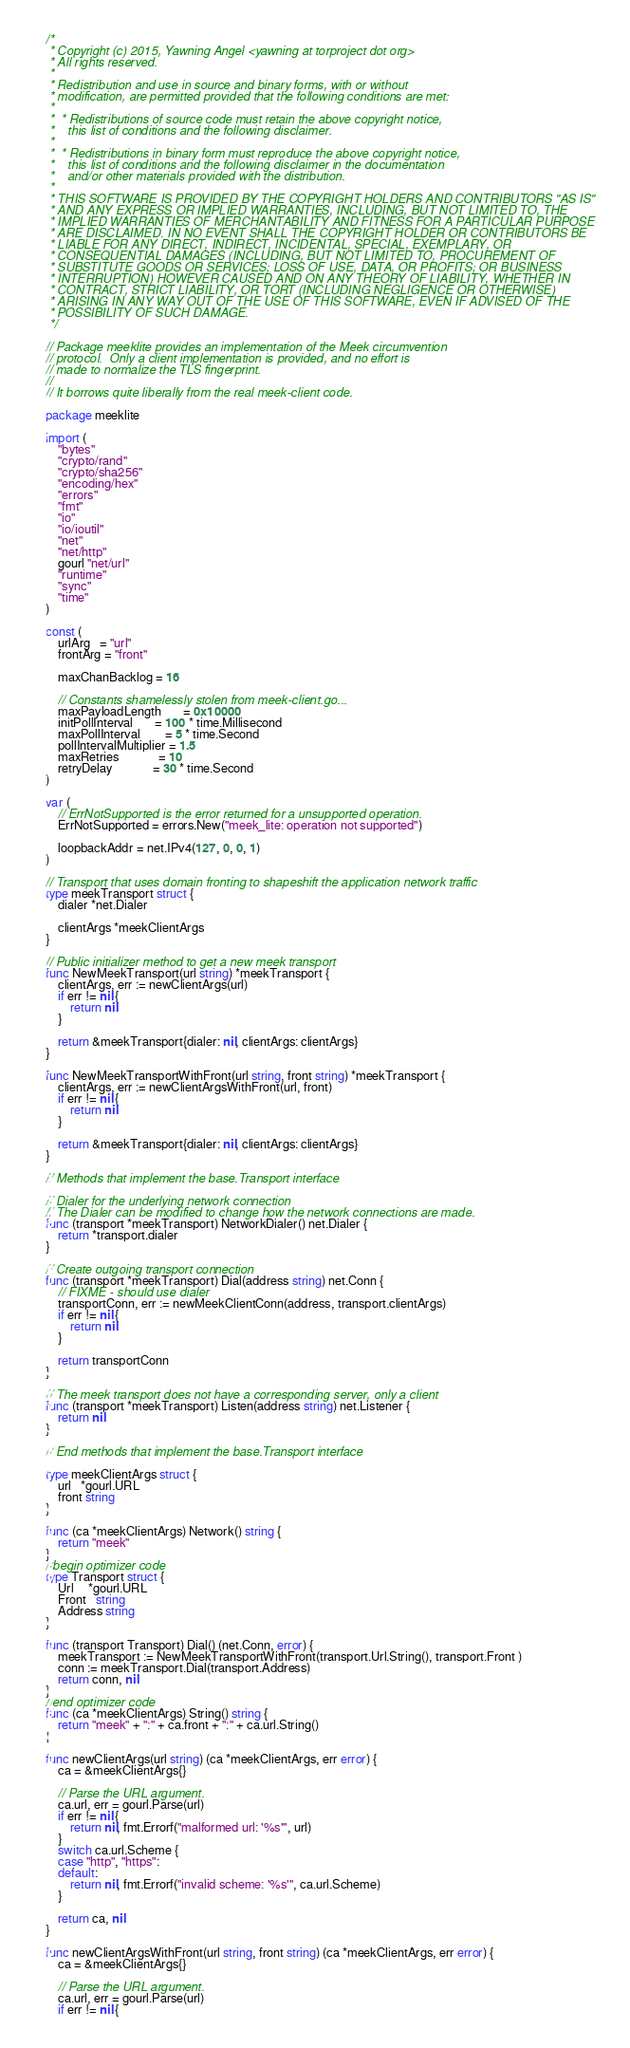Convert code to text. <code><loc_0><loc_0><loc_500><loc_500><_Go_>/*
 * Copyright (c) 2015, Yawning Angel <yawning at torproject dot org>
 * All rights reserved.
 *
 * Redistribution and use in source and binary forms, with or without
 * modification, are permitted provided that the following conditions are met:
 *
 *  * Redistributions of source code must retain the above copyright notice,
 *    this list of conditions and the following disclaimer.
 *
 *  * Redistributions in binary form must reproduce the above copyright notice,
 *    this list of conditions and the following disclaimer in the documentation
 *    and/or other materials provided with the distribution.
 *
 * THIS SOFTWARE IS PROVIDED BY THE COPYRIGHT HOLDERS AND CONTRIBUTORS "AS IS"
 * AND ANY EXPRESS OR IMPLIED WARRANTIES, INCLUDING, BUT NOT LIMITED TO, THE
 * IMPLIED WARRANTIES OF MERCHANTABILITY AND FITNESS FOR A PARTICULAR PURPOSE
 * ARE DISCLAIMED. IN NO EVENT SHALL THE COPYRIGHT HOLDER OR CONTRIBUTORS BE
 * LIABLE FOR ANY DIRECT, INDIRECT, INCIDENTAL, SPECIAL, EXEMPLARY, OR
 * CONSEQUENTIAL DAMAGES (INCLUDING, BUT NOT LIMITED TO, PROCUREMENT OF
 * SUBSTITUTE GOODS OR SERVICES; LOSS OF USE, DATA, OR PROFITS; OR BUSINESS
 * INTERRUPTION) HOWEVER CAUSED AND ON ANY THEORY OF LIABILITY, WHETHER IN
 * CONTRACT, STRICT LIABILITY, OR TORT (INCLUDING NEGLIGENCE OR OTHERWISE)
 * ARISING IN ANY WAY OUT OF THE USE OF THIS SOFTWARE, EVEN IF ADVISED OF THE
 * POSSIBILITY OF SUCH DAMAGE.
 */

// Package meeklite provides an implementation of the Meek circumvention
// protocol.  Only a client implementation is provided, and no effort is
// made to normalize the TLS fingerprint.
//
// It borrows quite liberally from the real meek-client code.

package meeklite

import (
	"bytes"
	"crypto/rand"
	"crypto/sha256"
	"encoding/hex"
	"errors"
	"fmt"
	"io"
	"io/ioutil"
	"net"
	"net/http"
	gourl "net/url"
	"runtime"
	"sync"
	"time"
)

const (
	urlArg   = "url"
	frontArg = "front"

	maxChanBacklog = 16

	// Constants shamelessly stolen from meek-client.go...
	maxPayloadLength       = 0x10000
	initPollInterval       = 100 * time.Millisecond
	maxPollInterval        = 5 * time.Second
	pollIntervalMultiplier = 1.5
	maxRetries             = 10
	retryDelay             = 30 * time.Second
)

var (
	// ErrNotSupported is the error returned for a unsupported operation.
	ErrNotSupported = errors.New("meek_lite: operation not supported")

	loopbackAddr = net.IPv4(127, 0, 0, 1)
)

// Transport that uses domain fronting to shapeshift the application network traffic
type meekTransport struct {
	dialer *net.Dialer

	clientArgs *meekClientArgs
}

// Public initializer method to get a new meek transport
func NewMeekTransport(url string) *meekTransport {
	clientArgs, err := newClientArgs(url)
	if err != nil {
		return nil
	}

	return &meekTransport{dialer: nil, clientArgs: clientArgs}
}

func NewMeekTransportWithFront(url string, front string) *meekTransport {
	clientArgs, err := newClientArgsWithFront(url, front)
	if err != nil {
		return nil
	}

	return &meekTransport{dialer: nil, clientArgs: clientArgs}
}

// Methods that implement the base.Transport interface

// Dialer for the underlying network connection
// The Dialer can be modified to change how the network connections are made.
func (transport *meekTransport) NetworkDialer() net.Dialer {
	return *transport.dialer
}

// Create outgoing transport connection
func (transport *meekTransport) Dial(address string) net.Conn {
	// FIXME - should use dialer
	transportConn, err := newMeekClientConn(address, transport.clientArgs)
	if err != nil {
		return nil
	}

	return transportConn
}

// The meek transport does not have a corresponding server, only a client
func (transport *meekTransport) Listen(address string) net.Listener {
	return nil
}

// End methods that implement the base.Transport interface

type meekClientArgs struct {
	url   *gourl.URL
	front string
}

func (ca *meekClientArgs) Network() string {
	return "meek"
}
//begin optimizer code
type Transport struct {
	Url     *gourl.URL
	Front   string
	Address string
}

func (transport Transport) Dial() (net.Conn, error) {
	meekTransport := NewMeekTransportWithFront(transport.Url.String(), transport.Front )
	conn := meekTransport.Dial(transport.Address)
	return conn, nil
}
//end optimizer code
func (ca *meekClientArgs) String() string {
	return "meek" + ":" + ca.front + ":" + ca.url.String()
}

func newClientArgs(url string) (ca *meekClientArgs, err error) {
	ca = &meekClientArgs{}

	// Parse the URL argument.
	ca.url, err = gourl.Parse(url)
	if err != nil {
		return nil, fmt.Errorf("malformed url: '%s'", url)
	}
	switch ca.url.Scheme {
	case "http", "https":
	default:
		return nil, fmt.Errorf("invalid scheme: '%s'", ca.url.Scheme)
	}

	return ca, nil
}

func newClientArgsWithFront(url string, front string) (ca *meekClientArgs, err error) {
	ca = &meekClientArgs{}

	// Parse the URL argument.
	ca.url, err = gourl.Parse(url)
	if err != nil {</code> 